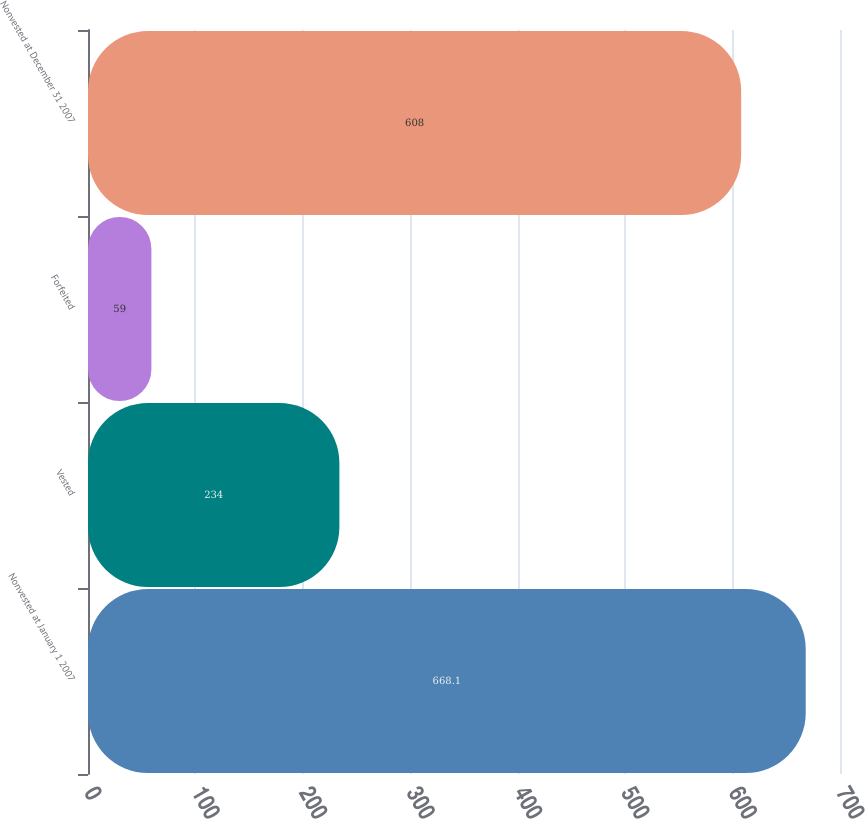<chart> <loc_0><loc_0><loc_500><loc_500><bar_chart><fcel>Nonvested at January 1 2007<fcel>Vested<fcel>Forfeited<fcel>Nonvested at December 31 2007<nl><fcel>668.1<fcel>234<fcel>59<fcel>608<nl></chart> 